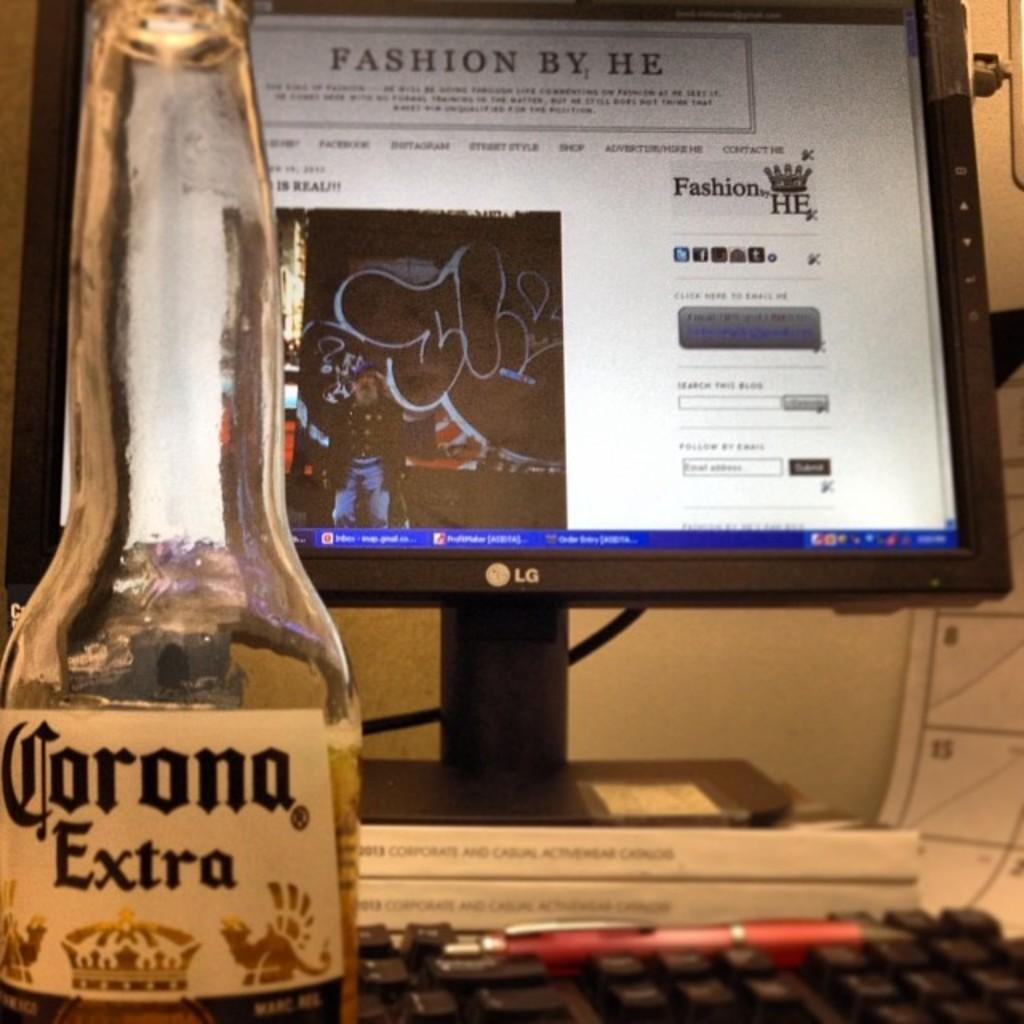What electronic device is on the table in the image? There is a computer on the table in the image. What is written on the computer? Something is written on the computer, but the specific content is not mentioned in the facts. What is placed in front of the computer? There is a wine bottle in front of the computer. What is used to input information into the computer? There is a keyboard on the side of the computer. What is placed on the keyboard? There is a pen on the keyboard. What can be seen in the background of the image? There is a wall visible in the image. What type of wax is being used to seal the computer in the image? There is no wax present in the image, and the computer is not being sealed. What type of gate can be seen in the image? There is no gate present in the image. 